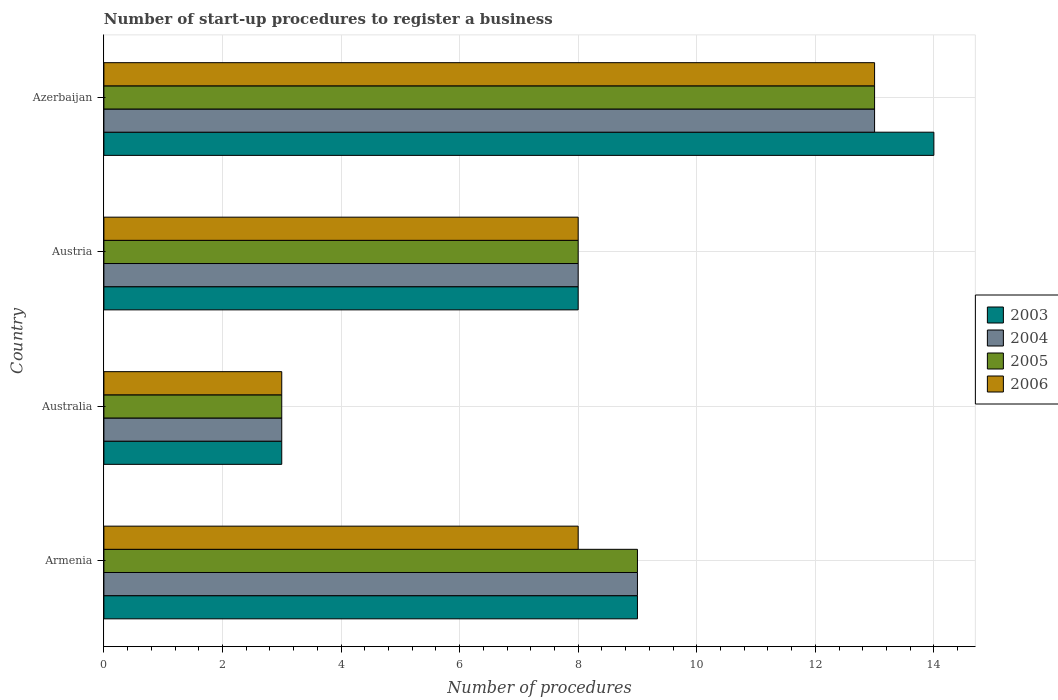How many bars are there on the 3rd tick from the top?
Keep it short and to the point. 4. What is the label of the 4th group of bars from the top?
Keep it short and to the point. Armenia. In how many cases, is the number of bars for a given country not equal to the number of legend labels?
Offer a very short reply. 0. Across all countries, what is the minimum number of procedures required to register a business in 2006?
Your answer should be compact. 3. In which country was the number of procedures required to register a business in 2004 maximum?
Ensure brevity in your answer.  Azerbaijan. What is the total number of procedures required to register a business in 2005 in the graph?
Keep it short and to the point. 33. What is the average number of procedures required to register a business in 2005 per country?
Make the answer very short. 8.25. What is the difference between the number of procedures required to register a business in 2003 and number of procedures required to register a business in 2004 in Azerbaijan?
Ensure brevity in your answer.  1. In how many countries, is the number of procedures required to register a business in 2003 greater than 6 ?
Provide a succinct answer. 3. What is the difference between the highest and the lowest number of procedures required to register a business in 2006?
Offer a terse response. 10. Is it the case that in every country, the sum of the number of procedures required to register a business in 2005 and number of procedures required to register a business in 2004 is greater than the sum of number of procedures required to register a business in 2006 and number of procedures required to register a business in 2003?
Provide a short and direct response. No. What does the 3rd bar from the bottom in Austria represents?
Ensure brevity in your answer.  2005. How many bars are there?
Offer a very short reply. 16. Are all the bars in the graph horizontal?
Provide a short and direct response. Yes. How many countries are there in the graph?
Provide a short and direct response. 4. What is the difference between two consecutive major ticks on the X-axis?
Your answer should be very brief. 2. Are the values on the major ticks of X-axis written in scientific E-notation?
Your answer should be compact. No. Does the graph contain any zero values?
Offer a terse response. No. Does the graph contain grids?
Your response must be concise. Yes. What is the title of the graph?
Your answer should be very brief. Number of start-up procedures to register a business. Does "1976" appear as one of the legend labels in the graph?
Your answer should be compact. No. What is the label or title of the X-axis?
Provide a short and direct response. Number of procedures. What is the label or title of the Y-axis?
Provide a succinct answer. Country. What is the Number of procedures in 2003 in Armenia?
Offer a terse response. 9. What is the Number of procedures of 2005 in Armenia?
Ensure brevity in your answer.  9. What is the Number of procedures in 2003 in Australia?
Give a very brief answer. 3. What is the Number of procedures in 2004 in Australia?
Your response must be concise. 3. What is the Number of procedures in 2006 in Australia?
Your answer should be compact. 3. What is the Number of procedures of 2004 in Austria?
Provide a short and direct response. 8. What is the Number of procedures in 2005 in Austria?
Keep it short and to the point. 8. What is the Number of procedures of 2006 in Austria?
Ensure brevity in your answer.  8. What is the Number of procedures in 2004 in Azerbaijan?
Give a very brief answer. 13. Across all countries, what is the maximum Number of procedures of 2005?
Keep it short and to the point. 13. Across all countries, what is the maximum Number of procedures of 2006?
Your answer should be very brief. 13. Across all countries, what is the minimum Number of procedures in 2004?
Your response must be concise. 3. Across all countries, what is the minimum Number of procedures of 2005?
Provide a succinct answer. 3. Across all countries, what is the minimum Number of procedures of 2006?
Offer a terse response. 3. What is the difference between the Number of procedures in 2003 in Armenia and that in Australia?
Keep it short and to the point. 6. What is the difference between the Number of procedures of 2005 in Armenia and that in Australia?
Provide a short and direct response. 6. What is the difference between the Number of procedures in 2004 in Armenia and that in Austria?
Keep it short and to the point. 1. What is the difference between the Number of procedures of 2006 in Armenia and that in Austria?
Offer a very short reply. 0. What is the difference between the Number of procedures in 2003 in Armenia and that in Azerbaijan?
Your answer should be very brief. -5. What is the difference between the Number of procedures of 2004 in Armenia and that in Azerbaijan?
Give a very brief answer. -4. What is the difference between the Number of procedures in 2006 in Armenia and that in Azerbaijan?
Provide a succinct answer. -5. What is the difference between the Number of procedures in 2003 in Australia and that in Austria?
Your answer should be very brief. -5. What is the difference between the Number of procedures in 2004 in Australia and that in Austria?
Ensure brevity in your answer.  -5. What is the difference between the Number of procedures of 2004 in Australia and that in Azerbaijan?
Make the answer very short. -10. What is the difference between the Number of procedures in 2005 in Australia and that in Azerbaijan?
Give a very brief answer. -10. What is the difference between the Number of procedures of 2004 in Austria and that in Azerbaijan?
Your response must be concise. -5. What is the difference between the Number of procedures in 2006 in Austria and that in Azerbaijan?
Make the answer very short. -5. What is the difference between the Number of procedures of 2003 in Armenia and the Number of procedures of 2004 in Australia?
Provide a succinct answer. 6. What is the difference between the Number of procedures of 2003 in Armenia and the Number of procedures of 2006 in Australia?
Your answer should be compact. 6. What is the difference between the Number of procedures of 2003 in Armenia and the Number of procedures of 2005 in Austria?
Your answer should be very brief. 1. What is the difference between the Number of procedures in 2003 in Armenia and the Number of procedures in 2006 in Austria?
Your answer should be compact. 1. What is the difference between the Number of procedures in 2004 in Armenia and the Number of procedures in 2006 in Austria?
Offer a terse response. 1. What is the difference between the Number of procedures of 2005 in Armenia and the Number of procedures of 2006 in Austria?
Give a very brief answer. 1. What is the difference between the Number of procedures in 2003 in Armenia and the Number of procedures in 2004 in Azerbaijan?
Give a very brief answer. -4. What is the difference between the Number of procedures in 2004 in Armenia and the Number of procedures in 2006 in Azerbaijan?
Make the answer very short. -4. What is the difference between the Number of procedures of 2003 in Australia and the Number of procedures of 2004 in Austria?
Ensure brevity in your answer.  -5. What is the difference between the Number of procedures in 2003 in Australia and the Number of procedures in 2005 in Austria?
Provide a succinct answer. -5. What is the difference between the Number of procedures in 2003 in Australia and the Number of procedures in 2006 in Austria?
Provide a succinct answer. -5. What is the difference between the Number of procedures of 2004 in Australia and the Number of procedures of 2006 in Austria?
Provide a succinct answer. -5. What is the difference between the Number of procedures in 2003 in Australia and the Number of procedures in 2005 in Azerbaijan?
Provide a succinct answer. -10. What is the difference between the Number of procedures in 2003 in Australia and the Number of procedures in 2006 in Azerbaijan?
Your response must be concise. -10. What is the difference between the Number of procedures in 2005 in Australia and the Number of procedures in 2006 in Azerbaijan?
Your answer should be compact. -10. What is the difference between the Number of procedures in 2003 in Austria and the Number of procedures in 2004 in Azerbaijan?
Provide a short and direct response. -5. What is the difference between the Number of procedures in 2003 in Austria and the Number of procedures in 2005 in Azerbaijan?
Ensure brevity in your answer.  -5. What is the difference between the Number of procedures of 2004 in Austria and the Number of procedures of 2006 in Azerbaijan?
Your response must be concise. -5. What is the difference between the Number of procedures in 2005 in Austria and the Number of procedures in 2006 in Azerbaijan?
Make the answer very short. -5. What is the average Number of procedures of 2004 per country?
Provide a short and direct response. 8.25. What is the average Number of procedures in 2005 per country?
Your answer should be very brief. 8.25. What is the difference between the Number of procedures of 2005 and Number of procedures of 2006 in Armenia?
Ensure brevity in your answer.  1. What is the difference between the Number of procedures in 2003 and Number of procedures in 2004 in Australia?
Give a very brief answer. 0. What is the difference between the Number of procedures of 2003 and Number of procedures of 2004 in Austria?
Provide a succinct answer. 0. What is the difference between the Number of procedures of 2003 and Number of procedures of 2005 in Austria?
Keep it short and to the point. 0. What is the difference between the Number of procedures in 2003 and Number of procedures in 2005 in Azerbaijan?
Offer a terse response. 1. What is the difference between the Number of procedures in 2004 and Number of procedures in 2005 in Azerbaijan?
Ensure brevity in your answer.  0. What is the difference between the Number of procedures in 2004 and Number of procedures in 2006 in Azerbaijan?
Offer a very short reply. 0. What is the difference between the Number of procedures in 2005 and Number of procedures in 2006 in Azerbaijan?
Provide a short and direct response. 0. What is the ratio of the Number of procedures in 2003 in Armenia to that in Australia?
Offer a terse response. 3. What is the ratio of the Number of procedures of 2004 in Armenia to that in Australia?
Offer a terse response. 3. What is the ratio of the Number of procedures in 2005 in Armenia to that in Australia?
Offer a very short reply. 3. What is the ratio of the Number of procedures of 2006 in Armenia to that in Australia?
Make the answer very short. 2.67. What is the ratio of the Number of procedures of 2004 in Armenia to that in Austria?
Your answer should be compact. 1.12. What is the ratio of the Number of procedures in 2006 in Armenia to that in Austria?
Give a very brief answer. 1. What is the ratio of the Number of procedures of 2003 in Armenia to that in Azerbaijan?
Provide a short and direct response. 0.64. What is the ratio of the Number of procedures of 2004 in Armenia to that in Azerbaijan?
Give a very brief answer. 0.69. What is the ratio of the Number of procedures of 2005 in Armenia to that in Azerbaijan?
Make the answer very short. 0.69. What is the ratio of the Number of procedures of 2006 in Armenia to that in Azerbaijan?
Offer a very short reply. 0.62. What is the ratio of the Number of procedures of 2003 in Australia to that in Azerbaijan?
Offer a very short reply. 0.21. What is the ratio of the Number of procedures in 2004 in Australia to that in Azerbaijan?
Offer a terse response. 0.23. What is the ratio of the Number of procedures in 2005 in Australia to that in Azerbaijan?
Your answer should be compact. 0.23. What is the ratio of the Number of procedures of 2006 in Australia to that in Azerbaijan?
Offer a terse response. 0.23. What is the ratio of the Number of procedures of 2003 in Austria to that in Azerbaijan?
Offer a very short reply. 0.57. What is the ratio of the Number of procedures in 2004 in Austria to that in Azerbaijan?
Offer a very short reply. 0.62. What is the ratio of the Number of procedures of 2005 in Austria to that in Azerbaijan?
Provide a succinct answer. 0.62. What is the ratio of the Number of procedures in 2006 in Austria to that in Azerbaijan?
Give a very brief answer. 0.62. What is the difference between the highest and the second highest Number of procedures of 2003?
Keep it short and to the point. 5. What is the difference between the highest and the second highest Number of procedures of 2004?
Offer a terse response. 4. What is the difference between the highest and the lowest Number of procedures of 2003?
Offer a very short reply. 11. What is the difference between the highest and the lowest Number of procedures of 2005?
Give a very brief answer. 10. What is the difference between the highest and the lowest Number of procedures in 2006?
Provide a short and direct response. 10. 